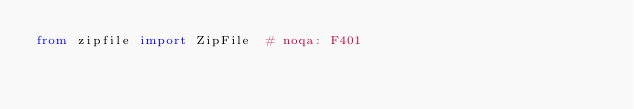Convert code to text. <code><loc_0><loc_0><loc_500><loc_500><_Python_>from zipfile import ZipFile  # noqa: F401
</code> 